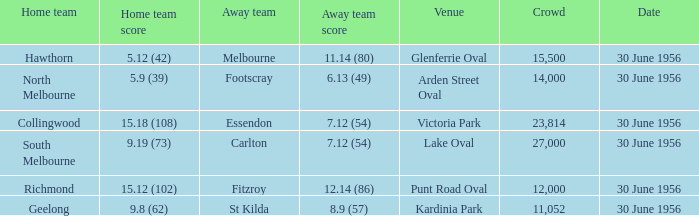What is the home team at Victoria Park with an Away team score of 7.12 (54) and more than 12,000 people? Collingwood. 